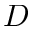<formula> <loc_0><loc_0><loc_500><loc_500>D</formula> 